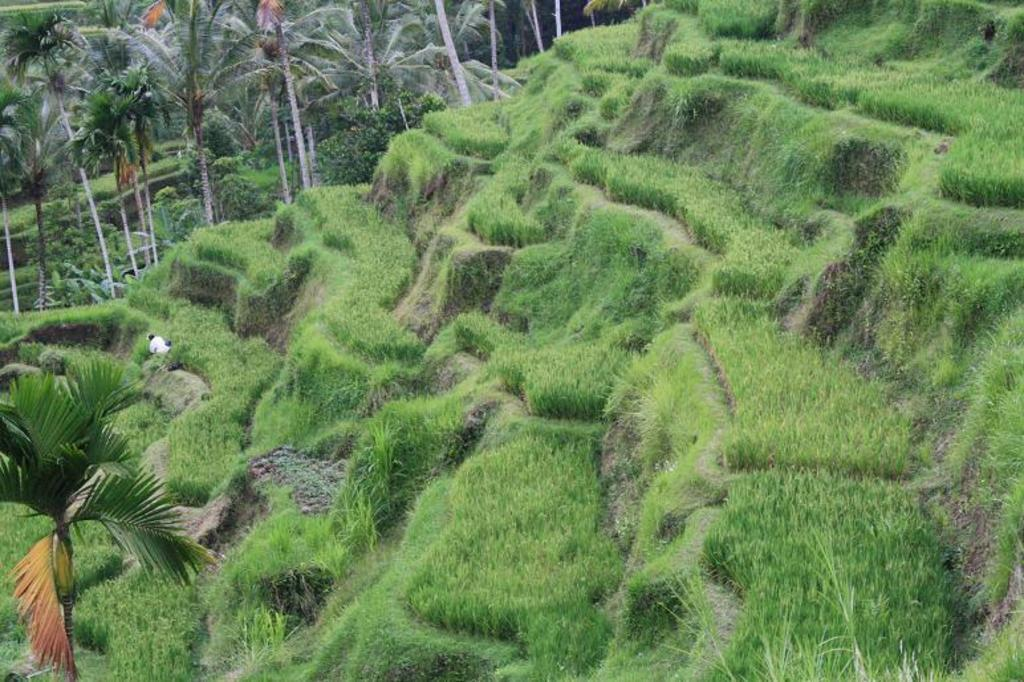What type of landscape feature is present in the image? There is a hill in the image. What can be found on the hill? There are steps on the hill with grass. Where is the tree located in the image? There is a tree in the bottom left corner of the image. What can be seen in the distance in the image? There are trees visible in the background of the image. What is the opinion of the tray in the image? There is no tray present in the image, so it is not possible to determine its opinion. 